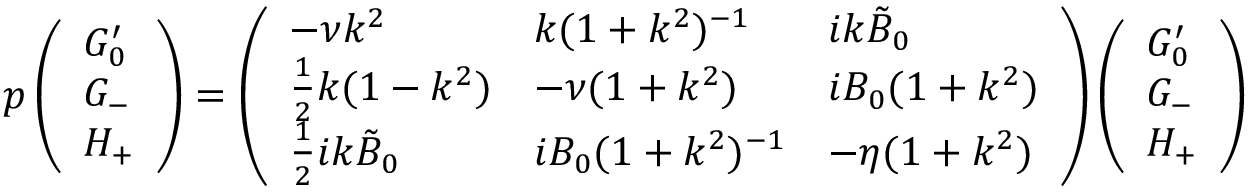Convert formula to latex. <formula><loc_0><loc_0><loc_500><loc_500>p \left ( \begin{array} { l } { G _ { 0 } ^ { \prime } } \\ { G _ { - } } \\ { H _ { + } } \end{array} \right ) = \left ( \begin{array} { l l l } { - \nu k ^ { 2 } } & { k ( 1 + k ^ { 2 } ) ^ { - 1 } } & { i k \tilde { B } _ { 0 } } \\ { \frac { 1 } { 2 } k ( 1 - k ^ { 2 } ) } & { - \nu ( 1 + k ^ { 2 } ) } & { i B _ { 0 } ( 1 + k ^ { 2 } ) } \\ { \frac { 1 } { 2 } i k \tilde { B } _ { 0 } } & { i B _ { 0 } ( 1 + k ^ { 2 } ) ^ { - 1 } } & { - \eta ( 1 + k ^ { 2 } ) } \end{array} \right ) \left ( \begin{array} { l } { G _ { 0 } ^ { \prime } } \\ { G _ { - } } \\ { H _ { + } } \end{array} \right )</formula> 